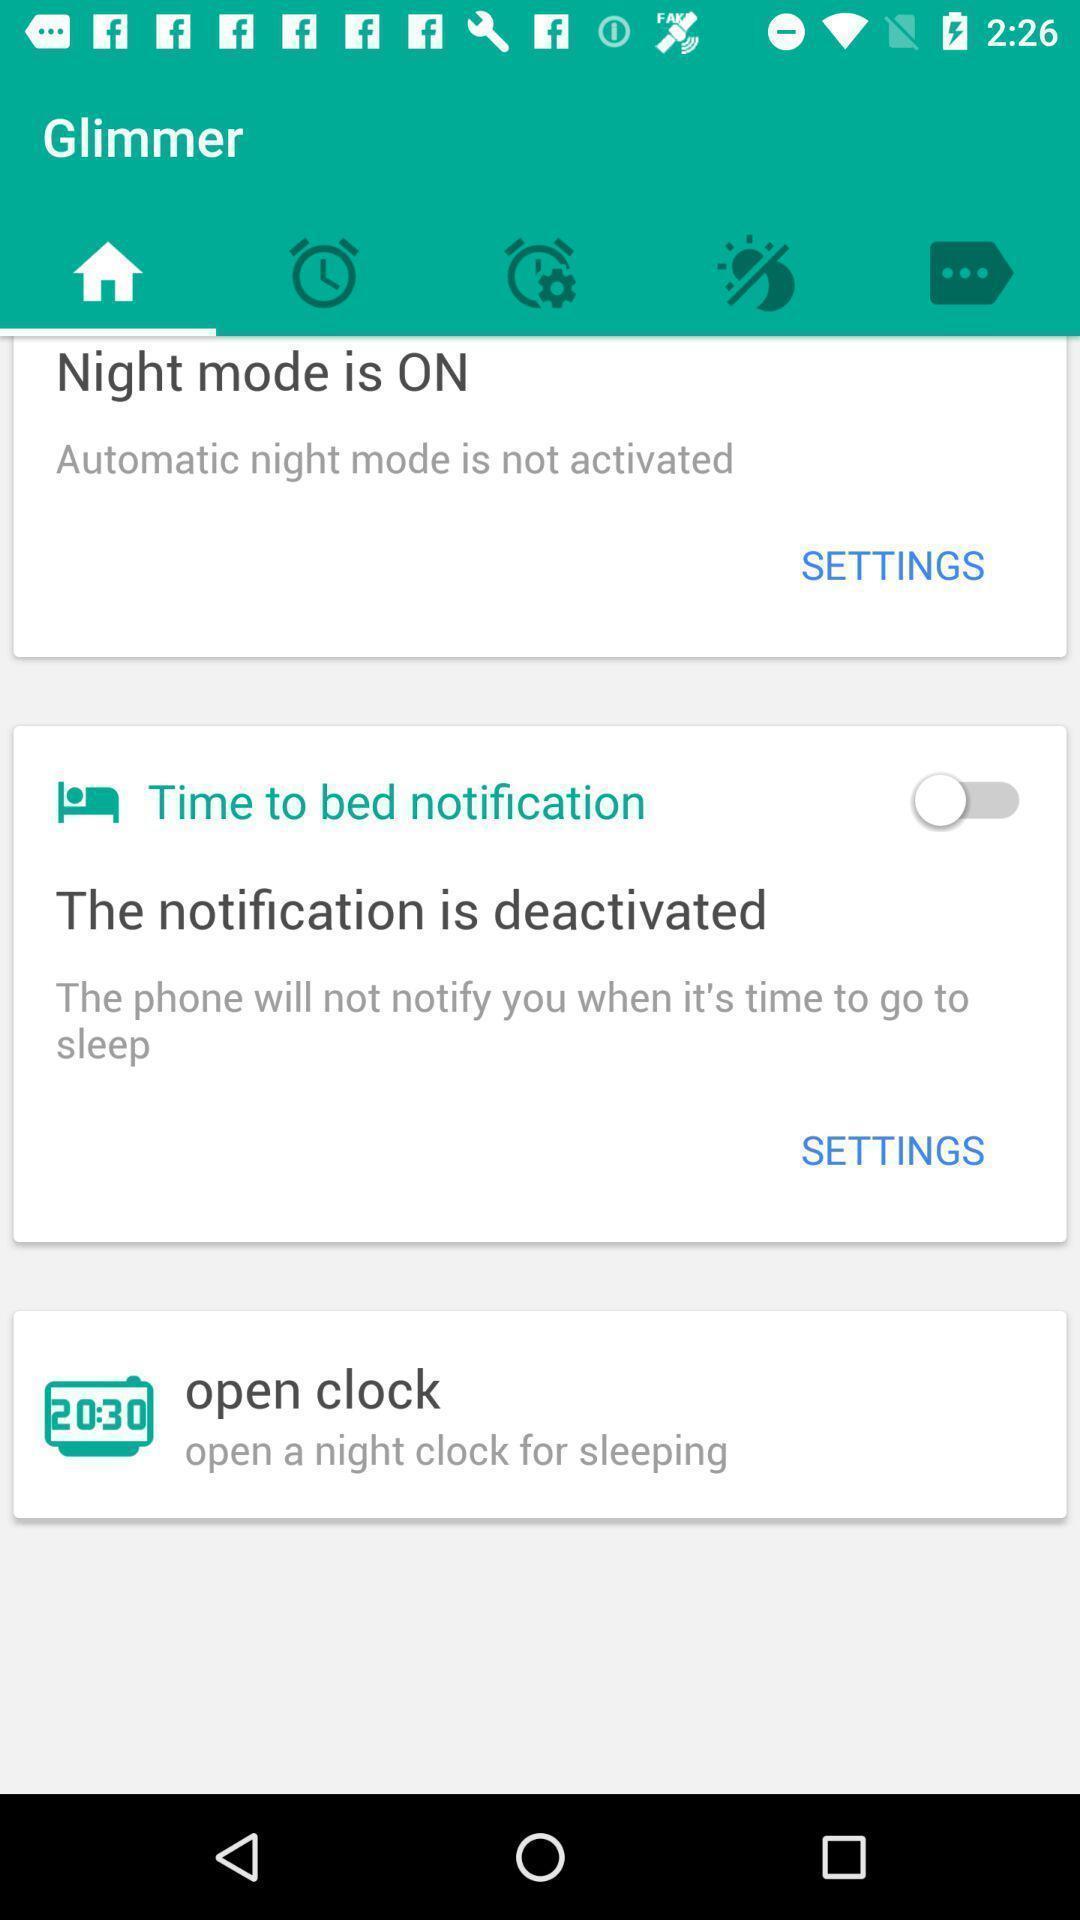Summarize the information in this screenshot. Page showing different settings. 